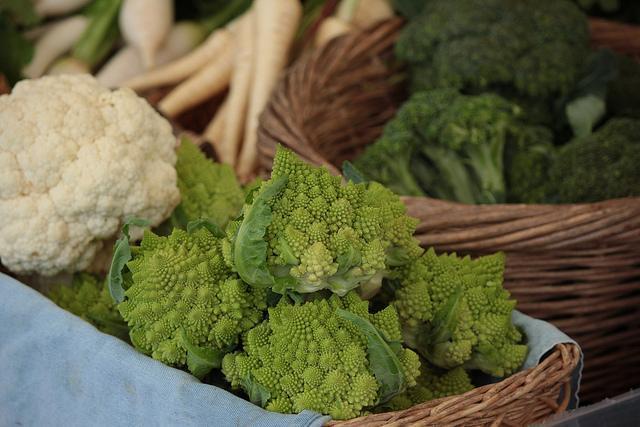What is the more realistic setting for these baskets of food items?
From the following set of four choices, select the accurate answer to respond to the question.
Options: Home, lemonade stand, farmer's market, grocery. Farmer's market. 